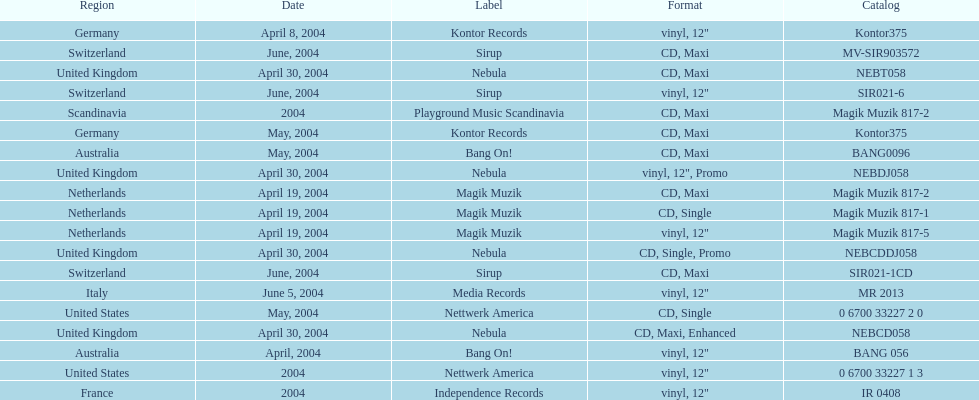What label was the only label to be used by france? Independence Records. 